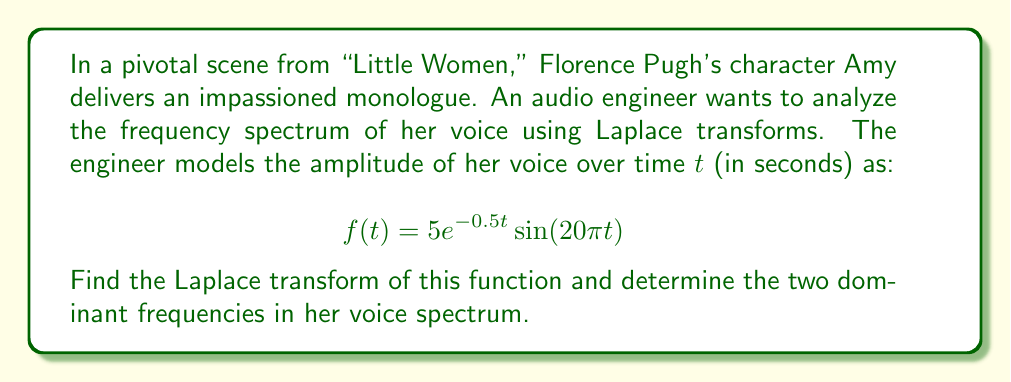Provide a solution to this math problem. Let's approach this step-by-step:

1) The Laplace transform of $f(t)$ is defined as:
   $$F(s) = \int_0^\infty f(t)e^{-st}dt$$

2) Substituting our function:
   $$F(s) = \int_0^\infty 5e^{-0.5t}\sin(20\pi t)e^{-st}dt$$

3) This can be rewritten as:
   $$F(s) = 5\int_0^\infty e^{-(s+0.5)t}\sin(20\pi t)dt$$

4) The Laplace transform of $e^{at}\sin(bt)$ is known to be:
   $$\mathcal{L}\{e^{at}\sin(bt)\} = \frac{b}{(s-a)^2 + b^2}$$

5) In our case, $a = -0.5$ and $b = 20\pi$. Substituting:
   $$F(s) = 5 \cdot \frac{20\pi}{(s+0.5)^2 + (20\pi)^2}$$

6) Simplifying:
   $$F(s) = \frac{100\pi}{(s+0.5)^2 + (20\pi)^2}$$

7) To find the dominant frequencies, we look at the poles of $F(s)$. The poles occur when the denominator is zero:
   $$(s+0.5)^2 + (20\pi)^2 = 0$$
   
8) Solving this:
   $$s+0.5 = \pm20\pi i$$
   $$s = -0.5 \pm 20\pi i$$

9) The imaginary parts of these poles represent the angular frequencies. To convert to Hz, we divide by $2\pi$:
   $$f_1 = \frac{20\pi}{2\pi} = 10 \text{ Hz}$$
   $$f_2 = \frac{-20\pi}{2\pi} = -10 \text{ Hz}$$

The negative frequency is just the mirror of the positive one in the frequency spectrum.
Answer: $F(s) = \frac{100\pi}{(s+0.5)^2 + (20\pi)^2}$; Dominant frequency: 10 Hz 